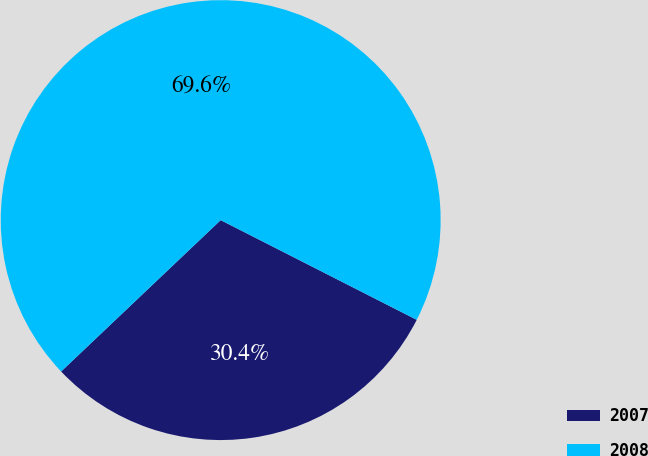Convert chart. <chart><loc_0><loc_0><loc_500><loc_500><pie_chart><fcel>2007<fcel>2008<nl><fcel>30.43%<fcel>69.57%<nl></chart> 